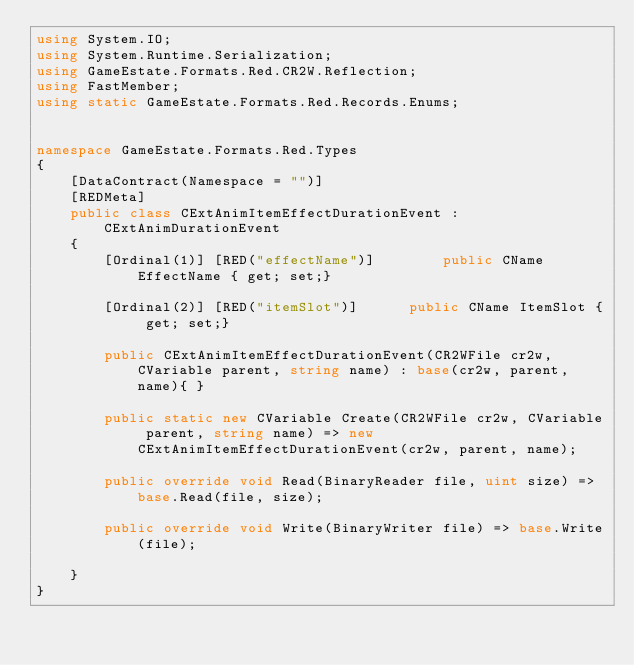<code> <loc_0><loc_0><loc_500><loc_500><_C#_>using System.IO;
using System.Runtime.Serialization;
using GameEstate.Formats.Red.CR2W.Reflection;
using FastMember;
using static GameEstate.Formats.Red.Records.Enums;


namespace GameEstate.Formats.Red.Types
{
	[DataContract(Namespace = "")]
	[REDMeta]
	public class CExtAnimItemEffectDurationEvent : CExtAnimDurationEvent
	{
		[Ordinal(1)] [RED("effectName")] 		public CName EffectName { get; set;}

		[Ordinal(2)] [RED("itemSlot")] 		public CName ItemSlot { get; set;}

		public CExtAnimItemEffectDurationEvent(CR2WFile cr2w, CVariable parent, string name) : base(cr2w, parent, name){ }

		public static new CVariable Create(CR2WFile cr2w, CVariable parent, string name) => new CExtAnimItemEffectDurationEvent(cr2w, parent, name);

		public override void Read(BinaryReader file, uint size) => base.Read(file, size);

		public override void Write(BinaryWriter file) => base.Write(file);

	}
}</code> 